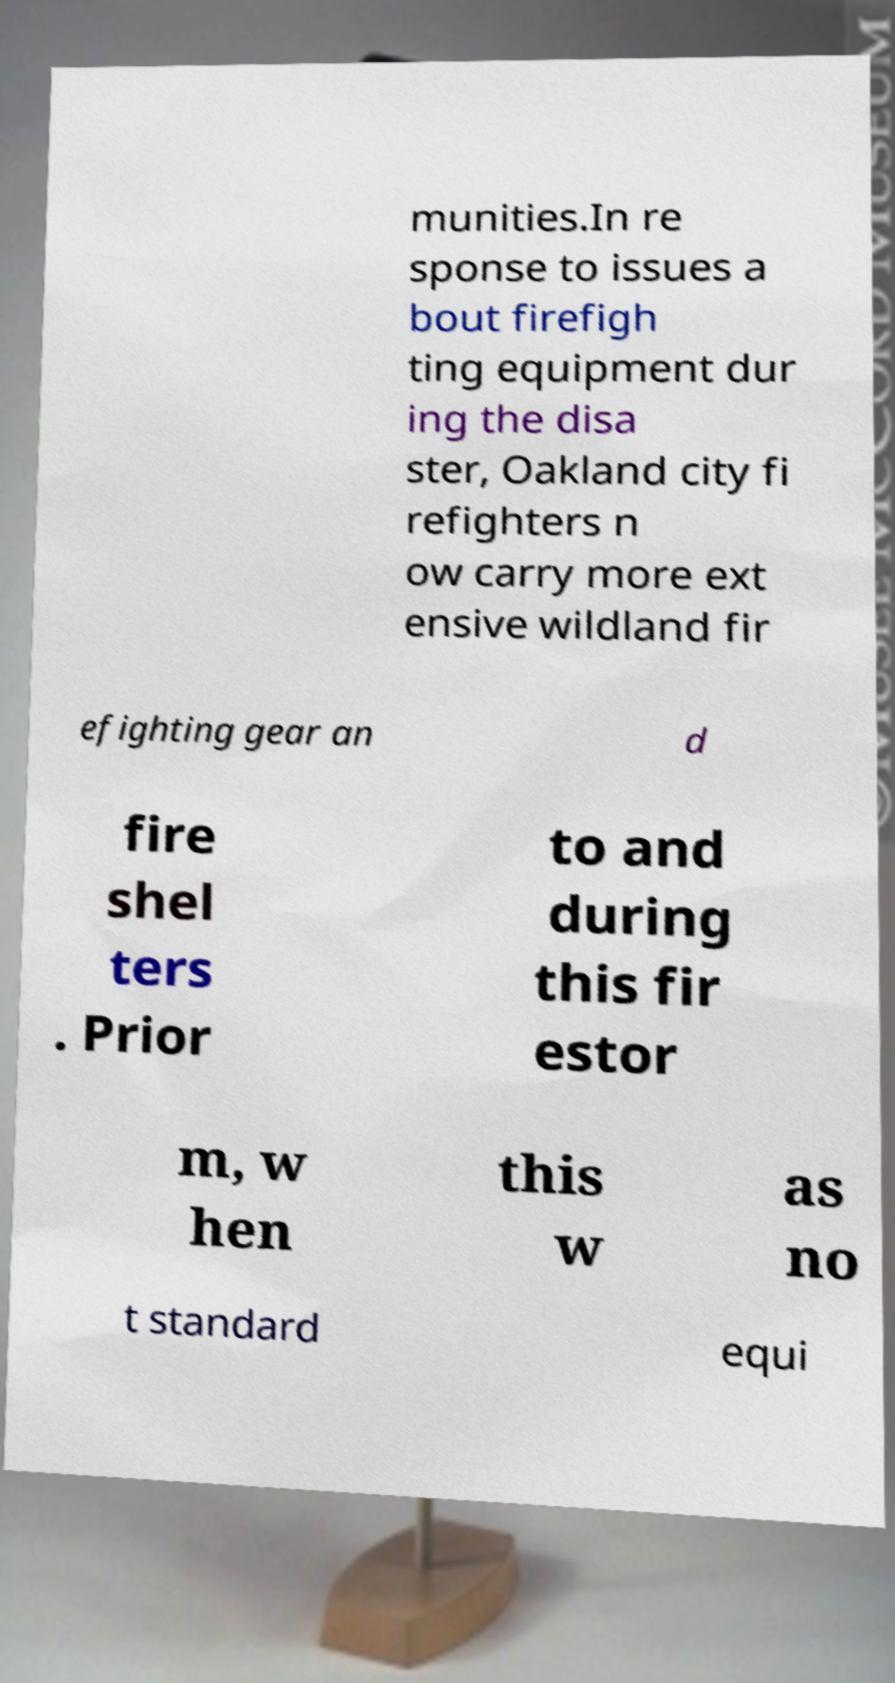Could you extract and type out the text from this image? munities.In re sponse to issues a bout firefigh ting equipment dur ing the disa ster, Oakland city fi refighters n ow carry more ext ensive wildland fir efighting gear an d fire shel ters . Prior to and during this fir estor m, w hen this w as no t standard equi 